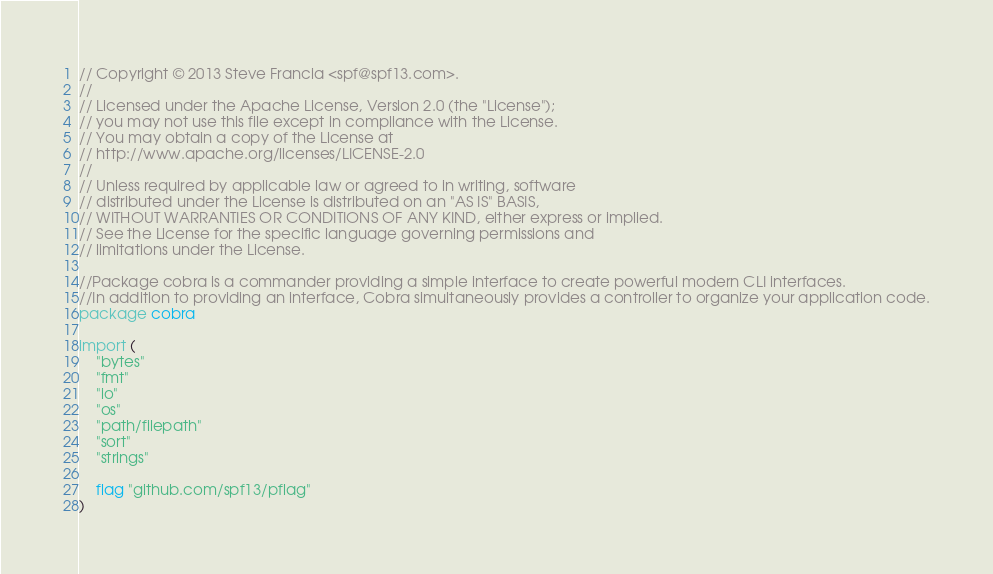Convert code to text. <code><loc_0><loc_0><loc_500><loc_500><_Go_>// Copyright © 2013 Steve Francia <spf@spf13.com>.
//
// Licensed under the Apache License, Version 2.0 (the "License");
// you may not use this file except in compliance with the License.
// You may obtain a copy of the License at
// http://www.apache.org/licenses/LICENSE-2.0
//
// Unless required by applicable law or agreed to in writing, software
// distributed under the License is distributed on an "AS IS" BASIS,
// WITHOUT WARRANTIES OR CONDITIONS OF ANY KIND, either express or implied.
// See the License for the specific language governing permissions and
// limitations under the License.

//Package cobra is a commander providing a simple interface to create powerful modern CLI interfaces.
//In addition to providing an interface, Cobra simultaneously provides a controller to organize your application code.
package cobra

import (
	"bytes"
	"fmt"
	"io"
	"os"
	"path/filepath"
	"sort"
	"strings"

	flag "github.com/spf13/pflag"
)
</code> 